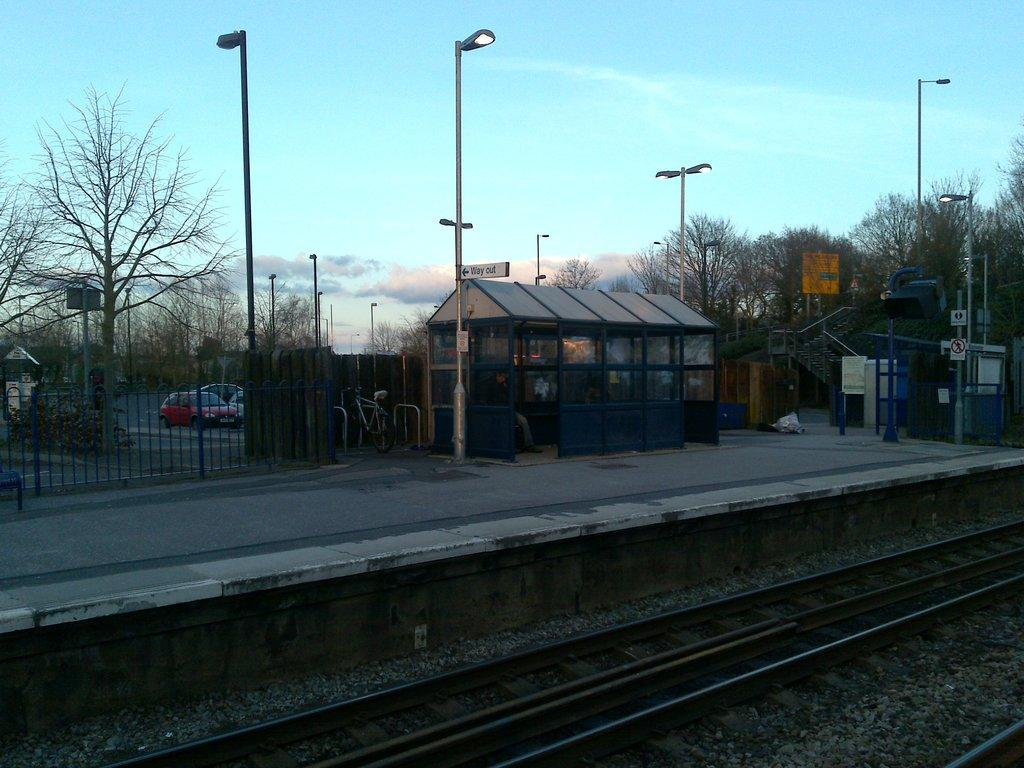What is the main feature in the image? There is a train track in the image. What can be seen in the background of the image? In the background of the image, there is a shed, trees, a fence, sign boards, and light poles. What is the weather like in the image? The sky is cloudy in the image. What objects are present in the image? There is a bicycle and vehicles visible in the image. Can you tell me how many planes are flying over the train track in the image? There are no planes visible in the image; it only features a train track, background elements, a bicycle, and vehicles. Is there a dog accompanying the bicycle in the image? There is no dog present in the image; only a bicycle and vehicles are visible. 